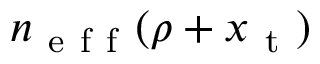Convert formula to latex. <formula><loc_0><loc_0><loc_500><loc_500>n _ { e f f } ( \rho + x _ { t } )</formula> 